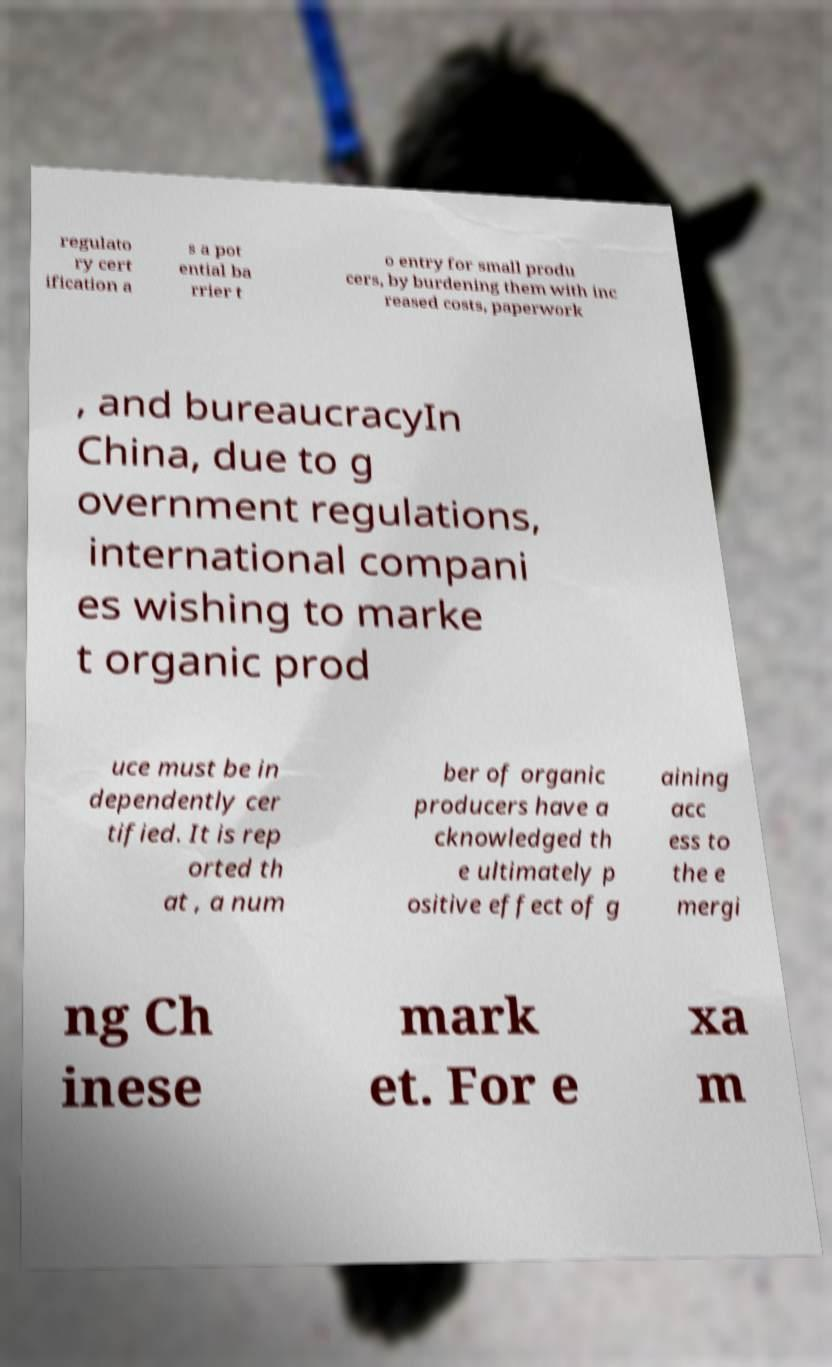I need the written content from this picture converted into text. Can you do that? regulato ry cert ification a s a pot ential ba rrier t o entry for small produ cers, by burdening them with inc reased costs, paperwork , and bureaucracyIn China, due to g overnment regulations, international compani es wishing to marke t organic prod uce must be in dependently cer tified. It is rep orted th at , a num ber of organic producers have a cknowledged th e ultimately p ositive effect of g aining acc ess to the e mergi ng Ch inese mark et. For e xa m 